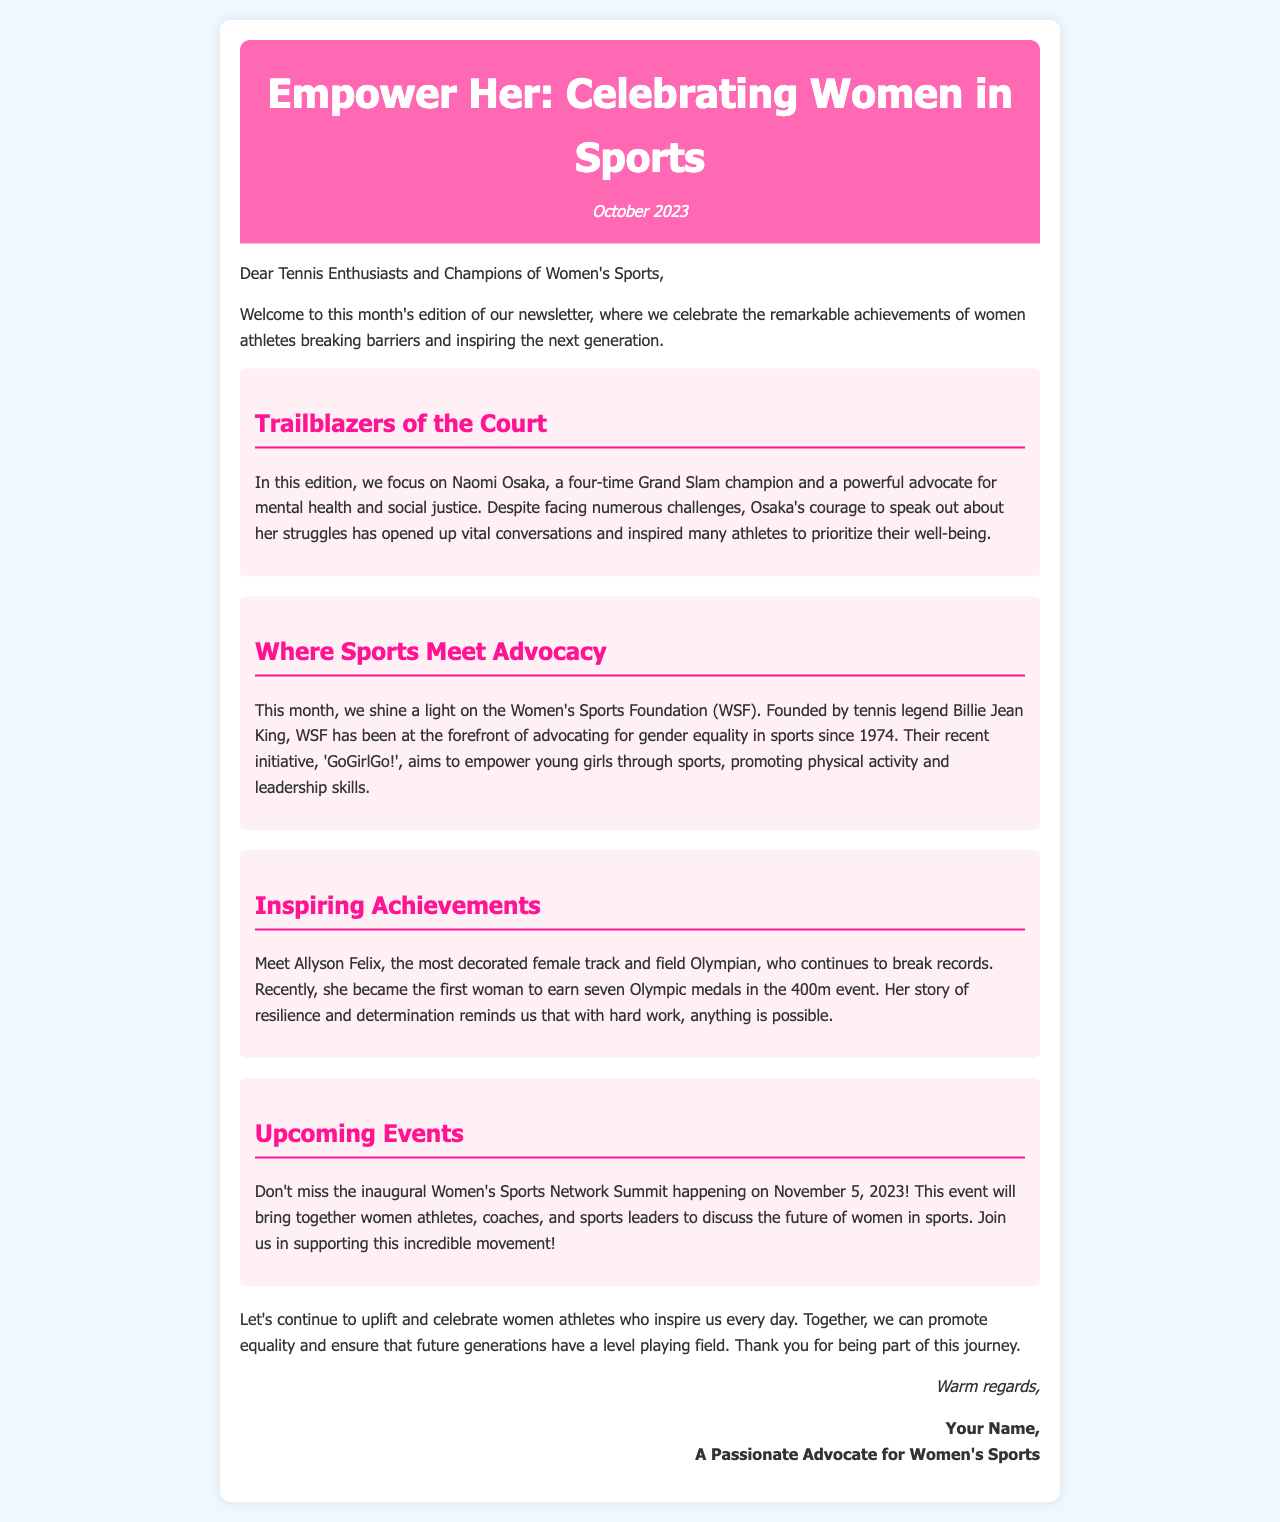What is the title of the newsletter? The title of the newsletter is located at the top of the document.
Answer: Empower Her: Celebrating Women in Sports Who is featured as "Trailblazer of the Court"? The section highlights a prominent female athlete celebrated for her advocacy.
Answer: Naomi Osaka What event is happening on November 5, 2023? The document mentions an upcoming event related to women's sports with a specific date.
Answer: Women's Sports Network Summit How many Olympic medals has Allyson Felix earned? The newsletter states Allyson Felix's achievement in terms of Olympic medals.
Answer: Seven Who founded the Women's Sports Foundation? The document attributes the founding of WSF to a well-known tennis figure.
Answer: Billie Jean King What initiative does the Women's Sports Foundation promote? The document refers to a specific initiative aimed at empowering young girls.
Answer: GoGirlGo! What does Naomi Osaka advocate for? The section discusses the themes Osaka supports, focusing on her public efforts.
Answer: Mental health and social justice What is the date of the newsletter? The newsletter's date is mentioned near the title section.
Answer: October 2023 